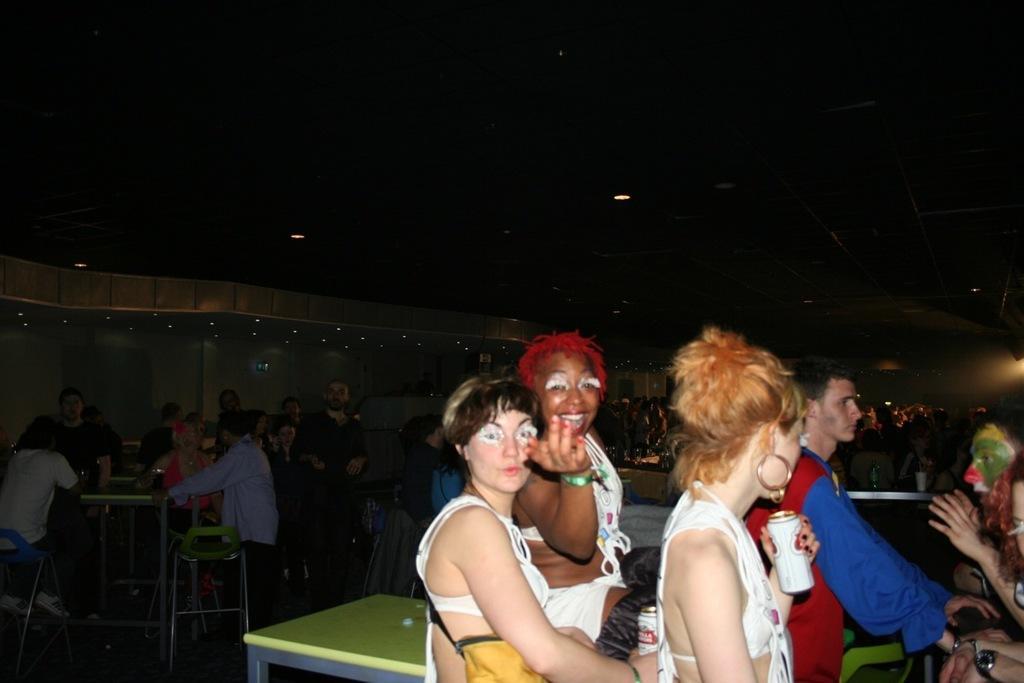Could you give a brief overview of what you see in this image? In this image I can see the group of people. some of them are sitting and some are standing. From them one person is holding a tin. In front of them there is a table. 